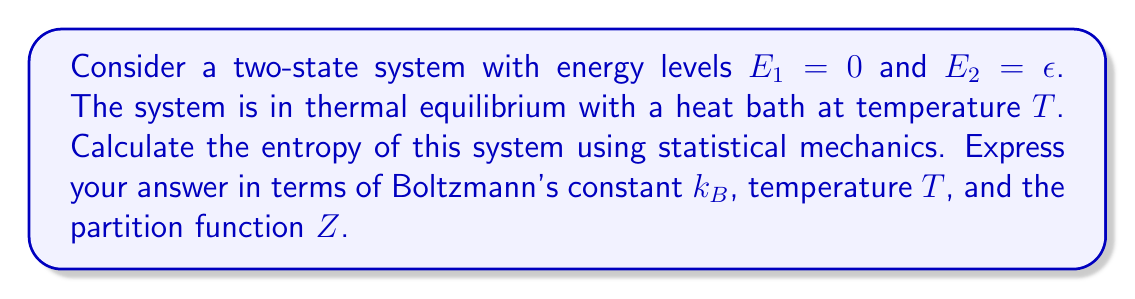Can you answer this question? Let's approach this step-by-step:

1) First, we need to calculate the partition function $Z$. For a two-state system:

   $$Z = e^{-\beta E_1} + e^{-\beta E_2} = 1 + e^{-\beta \epsilon}$$

   where $\beta = \frac{1}{k_B T}$

2) The probability of the system being in each state is:

   $$p_1 = \frac{e^{-\beta E_1}}{Z} = \frac{1}{Z}$$
   $$p_2 = \frac{e^{-\beta E_2}}{Z} = \frac{e^{-\beta \epsilon}}{Z}$$

3) The entropy in statistical mechanics is given by:

   $$S = -k_B \sum_i p_i \ln p_i$$

4) Substituting the probabilities:

   $$S = -k_B \left(\frac{1}{Z} \ln \frac{1}{Z} + \frac{e^{-\beta \epsilon}}{Z} \ln \frac{e^{-\beta \epsilon}}{Z}\right)$$

5) Simplify:

   $$S = -k_B \left(\frac{1}{Z} \ln \frac{1}{Z} + \frac{e^{-\beta \epsilon}}{Z} (\ln e^{-\beta \epsilon} - \ln Z)\right)$$
   $$S = -k_B \left(\frac{1}{Z} \ln \frac{1}{Z} + \frac{e^{-\beta \epsilon}}{Z} (-\beta \epsilon - \ln Z)\right)$$

6) Factor out $-\frac{1}{Z} \ln Z$:

   $$S = k_B \ln Z - k_B \frac{e^{-\beta \epsilon}}{Z} \beta \epsilon$$

7) Recognize that $\frac{e^{-\beta \epsilon}}{Z} = p_2$ and $\beta \epsilon = \frac{\epsilon}{k_B T}$:

   $$S = k_B \ln Z - \frac{\epsilon}{T} p_2$$

8) The average energy $\langle E \rangle = \epsilon p_2$, so:

   $$S = k_B \ln Z - \frac{\langle E \rangle}{T}$$

This is the final expression for the entropy of the two-state system.
Answer: $S = k_B \ln Z - \frac{\langle E \rangle}{T}$ 